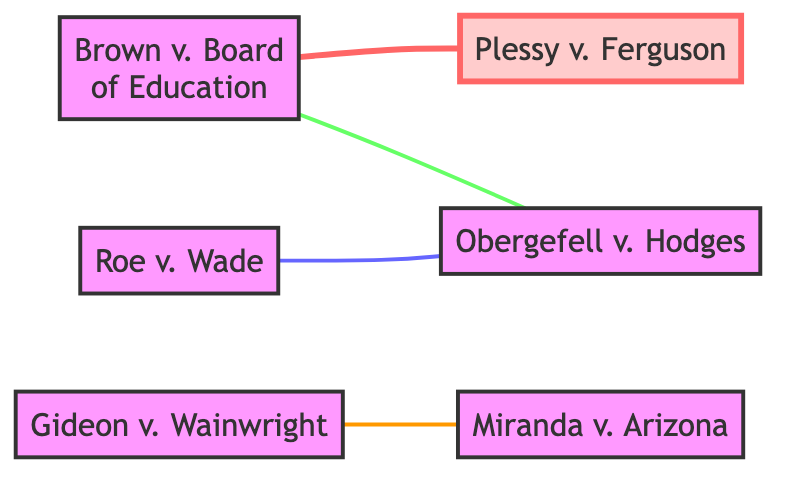What is the landmark case that declared racial segregation in public schools unconstitutional? The diagram lists "Brown v. Board of Education" as a node with the description stating it declared racial segregation unconstitutional, making it the answer.
Answer: Brown v. Board of Education Which case is a landmark decision on the issue of abortion? By examining the nodes in the diagram, "Roe v. Wade" is identified with a description specifying it as a landmark decision on abortion, thus providing the answer.
Answer: Roe v. Wade How many nodes are present in the diagram? The diagram shows a total of six nodes: Brown v. Board of Education, Roe v. Wade, Miranda v. Arizona, Gideon v. Wainwright, Plessy v. Ferguson, and Obergefell v. Hodges, which can be counted directly.
Answer: 6 What is the relationship between Gideon v. Wainwright and Miranda v. Arizona? The diagram illustrates that there is a connection labeled "Expanded Right to Counsel" between these two cases, indicating a direct relationship between them.
Answer: Expanded Right to Counsel Which case overturned Plessy v. Ferguson? The diagram indicates that "Brown v. Board of Education" is connected to "Plessy v. Ferguson" with an "Overturned" relationship, explicitly stating that it is the case that overturned it.
Answer: Brown v. Board of Education What type of rights did Roe v. Wade protect in relation to Obergefell v. Hodges? The relationship labeled "Civil Liberties Protection" between Roe v. Wade and Obergefell v. Hodges signifies that Roe v. Wade protects civil liberties, linking the two cases on these grounds.
Answer: Civil Liberties Protection How many edges are connecting nodes in the diagram? The diagram includes four edges: two from Brown v. Board, one from Gideon v. Wainwright, and one from Roe v. Wade to Obergefell v. Hodges, which can be counted to provide the answer.
Answer: 4 Which case established the requirement to inform suspects of their rights? The diagram describes "Miranda v. Arizona" as the case that established Miranda rights, indicating that it is the specific case meeting this criterion.
Answer: Miranda v. Arizona Is Obergefell v. Hodges connected to any cases regarding civil rights? The diagram shows that "Brown v. Board of Education" connects to Obergefell v. Hodges via "Civil Rights Expansion," confirming that Obergefell is indeed connected to civil rights cases.
Answer: Yes 